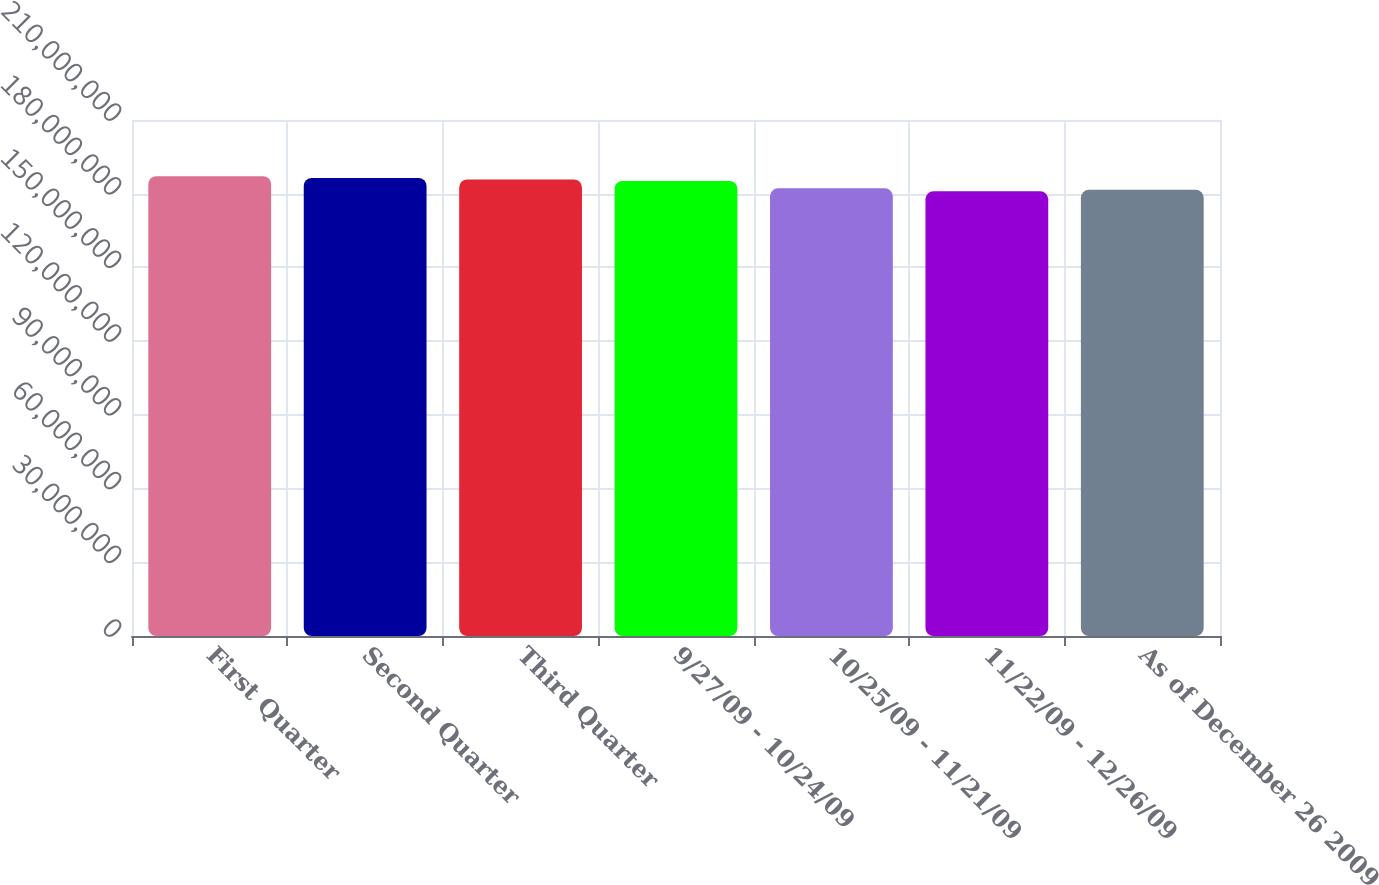Convert chart. <chart><loc_0><loc_0><loc_500><loc_500><bar_chart><fcel>First Quarter<fcel>Second Quarter<fcel>Third Quarter<fcel>9/27/09 - 10/24/09<fcel>10/25/09 - 11/21/09<fcel>11/22/09 - 12/26/09<fcel>As of December 26 2009<nl><fcel>1.8712e+08<fcel>1.86423e+08<fcel>1.85806e+08<fcel>1.8519e+08<fcel>1.82186e+08<fcel>1.80953e+08<fcel>1.8157e+08<nl></chart> 